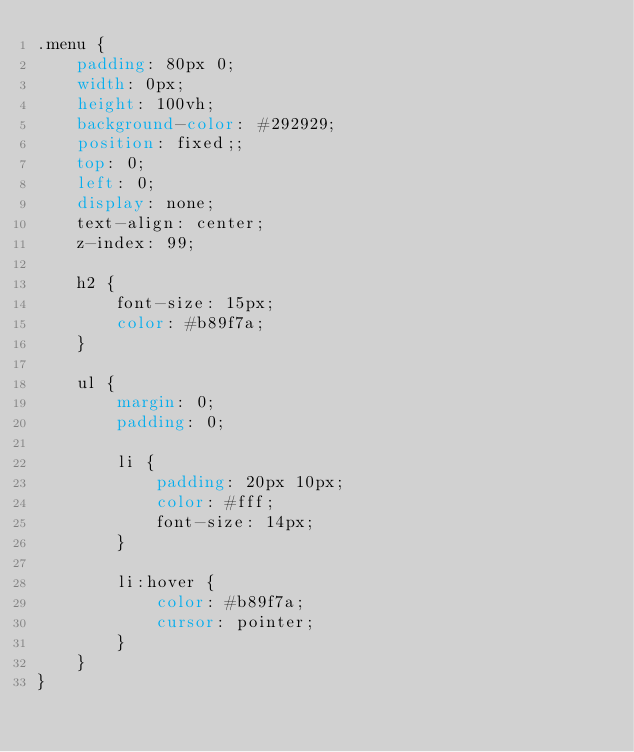<code> <loc_0><loc_0><loc_500><loc_500><_CSS_>.menu {
    padding: 80px 0;
    width: 0px;
    height: 100vh;
    background-color: #292929;
    position: fixed;;
    top: 0;
    left: 0;
    display: none;
    text-align: center;
    z-index: 99;

    h2 {
        font-size: 15px;
        color: #b89f7a;
    }

    ul {
        margin: 0;
        padding: 0;

        li {
            padding: 20px 10px;
            color: #fff;
            font-size: 14px;
        }

        li:hover {
            color: #b89f7a;
            cursor: pointer;
        }
    }
}
</code> 